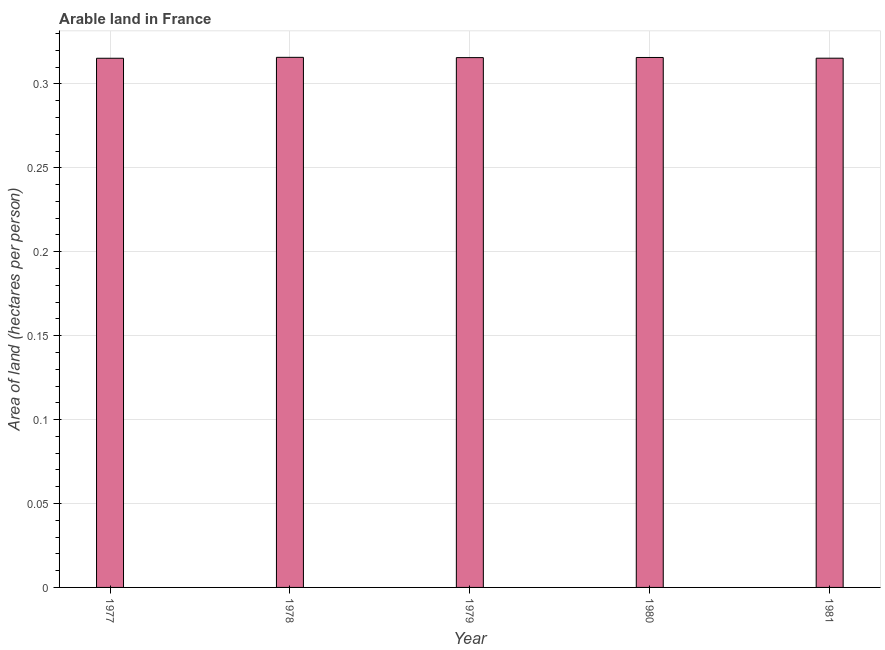Does the graph contain grids?
Give a very brief answer. Yes. What is the title of the graph?
Keep it short and to the point. Arable land in France. What is the label or title of the Y-axis?
Your answer should be very brief. Area of land (hectares per person). What is the area of arable land in 1977?
Your answer should be compact. 0.32. Across all years, what is the maximum area of arable land?
Provide a short and direct response. 0.32. Across all years, what is the minimum area of arable land?
Your response must be concise. 0.32. In which year was the area of arable land maximum?
Offer a very short reply. 1978. In which year was the area of arable land minimum?
Provide a short and direct response. 1977. What is the sum of the area of arable land?
Offer a terse response. 1.58. What is the average area of arable land per year?
Your answer should be compact. 0.32. What is the median area of arable land?
Make the answer very short. 0.32. Is the area of arable land in 1980 less than that in 1981?
Provide a short and direct response. No. Is the difference between the area of arable land in 1979 and 1980 greater than the difference between any two years?
Offer a terse response. No. In how many years, is the area of arable land greater than the average area of arable land taken over all years?
Provide a short and direct response. 3. Are all the bars in the graph horizontal?
Provide a short and direct response. No. Are the values on the major ticks of Y-axis written in scientific E-notation?
Your answer should be compact. No. What is the Area of land (hectares per person) of 1977?
Your answer should be compact. 0.32. What is the Area of land (hectares per person) in 1978?
Make the answer very short. 0.32. What is the Area of land (hectares per person) of 1979?
Your answer should be compact. 0.32. What is the Area of land (hectares per person) in 1980?
Provide a short and direct response. 0.32. What is the Area of land (hectares per person) in 1981?
Your answer should be very brief. 0.32. What is the difference between the Area of land (hectares per person) in 1977 and 1978?
Give a very brief answer. -0. What is the difference between the Area of land (hectares per person) in 1977 and 1979?
Give a very brief answer. -0. What is the difference between the Area of land (hectares per person) in 1977 and 1980?
Keep it short and to the point. -0. What is the difference between the Area of land (hectares per person) in 1977 and 1981?
Provide a short and direct response. -4e-5. What is the difference between the Area of land (hectares per person) in 1978 and 1979?
Offer a very short reply. 0. What is the difference between the Area of land (hectares per person) in 1978 and 1980?
Give a very brief answer. 9e-5. What is the difference between the Area of land (hectares per person) in 1978 and 1981?
Your response must be concise. 0. What is the difference between the Area of land (hectares per person) in 1979 and 1980?
Give a very brief answer. -8e-5. What is the difference between the Area of land (hectares per person) in 1979 and 1981?
Make the answer very short. 0. What is the difference between the Area of land (hectares per person) in 1980 and 1981?
Keep it short and to the point. 0. What is the ratio of the Area of land (hectares per person) in 1977 to that in 1981?
Keep it short and to the point. 1. What is the ratio of the Area of land (hectares per person) in 1978 to that in 1980?
Your answer should be very brief. 1. What is the ratio of the Area of land (hectares per person) in 1978 to that in 1981?
Provide a succinct answer. 1. What is the ratio of the Area of land (hectares per person) in 1979 to that in 1980?
Make the answer very short. 1. What is the ratio of the Area of land (hectares per person) in 1979 to that in 1981?
Your answer should be compact. 1. What is the ratio of the Area of land (hectares per person) in 1980 to that in 1981?
Your answer should be very brief. 1. 